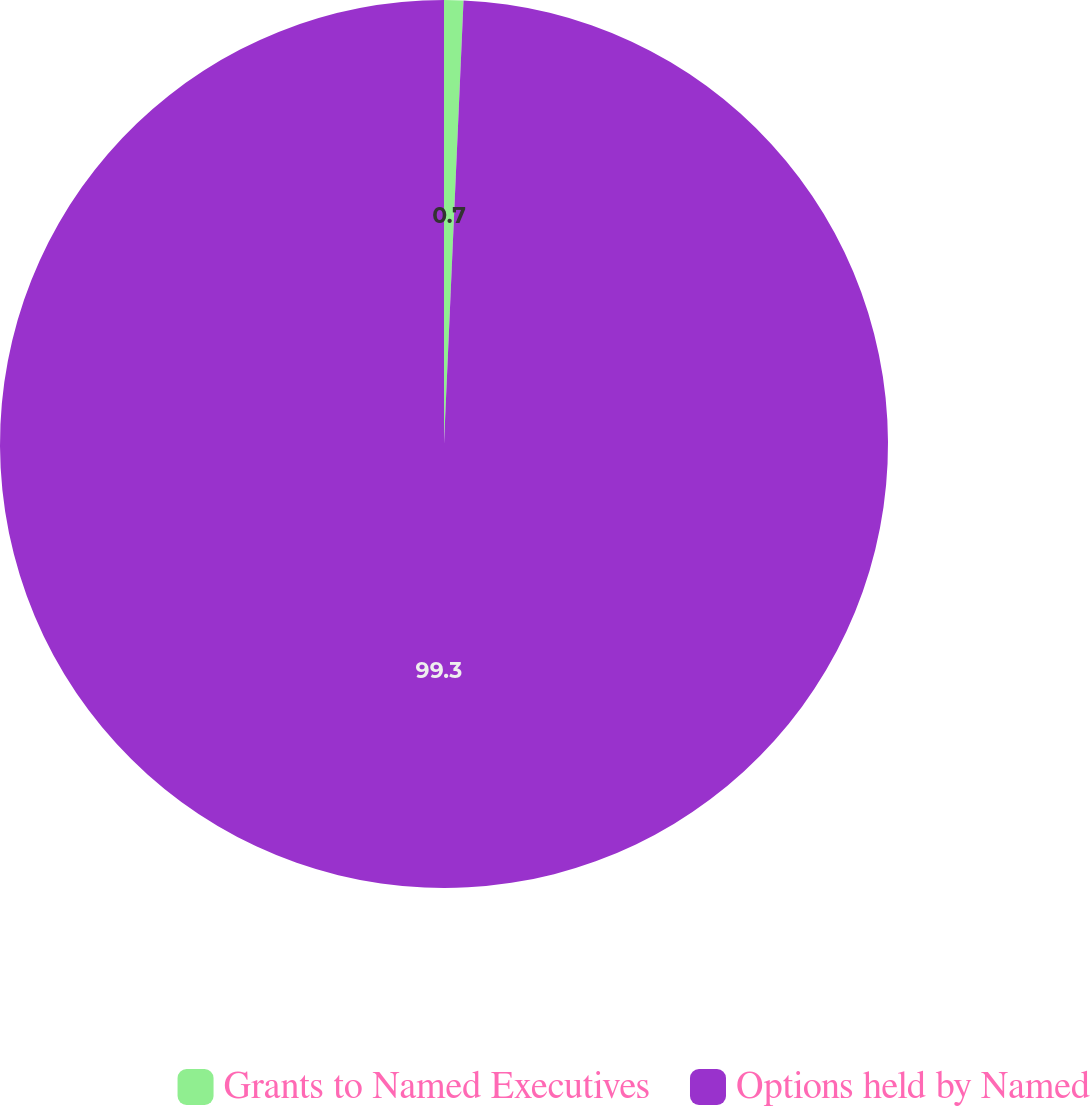Convert chart to OTSL. <chart><loc_0><loc_0><loc_500><loc_500><pie_chart><fcel>Grants to Named Executives<fcel>Options held by Named<nl><fcel>0.7%<fcel>99.3%<nl></chart> 